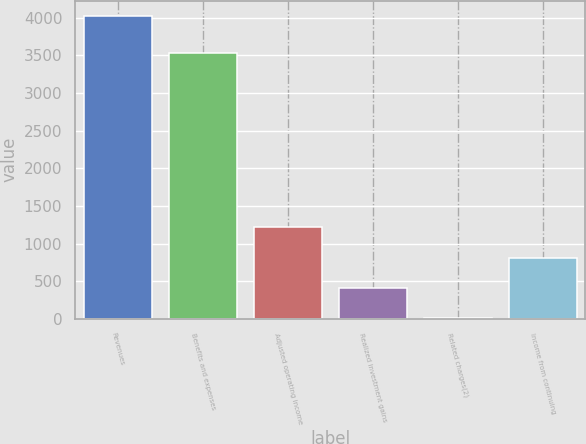Convert chart to OTSL. <chart><loc_0><loc_0><loc_500><loc_500><bar_chart><fcel>Revenues<fcel>Benefits and expenses<fcel>Adjusted operating income<fcel>Realized investment gains<fcel>Related charges(2)<fcel>Income from continuing<nl><fcel>4025<fcel>3527<fcel>1215.9<fcel>413.3<fcel>12<fcel>814.6<nl></chart> 